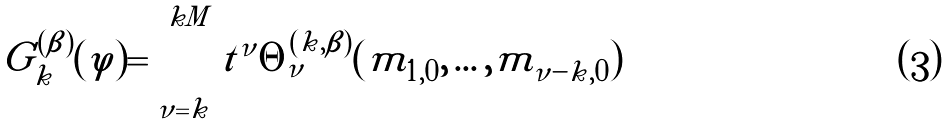<formula> <loc_0><loc_0><loc_500><loc_500>G _ { k } ^ { ( \beta ) } ( \varphi ) = \sum _ { \nu = k } ^ { k M } t ^ { \nu } \Theta _ { \nu } ^ { ( k , \beta ) } ( m _ { 1 , 0 } , \dots , m _ { \nu - k , 0 } )</formula> 